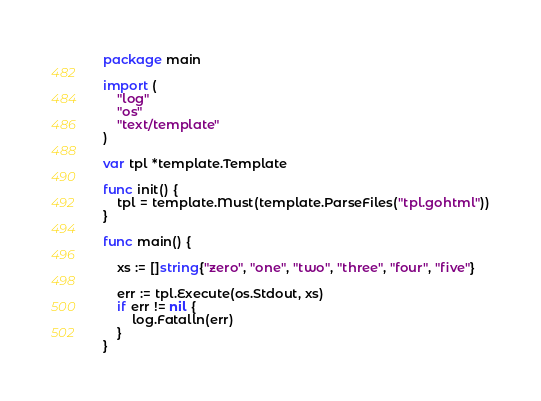<code> <loc_0><loc_0><loc_500><loc_500><_Go_>package main

import (
	"log"
	"os"
	"text/template"
)

var tpl *template.Template

func init() {
	tpl = template.Must(template.ParseFiles("tpl.gohtml"))
}

func main() {

	xs := []string{"zero", "one", "two", "three", "four", "five"}

	err := tpl.Execute(os.Stdout, xs)
	if err != nil {
		log.Fatalln(err)
	}
}
</code> 